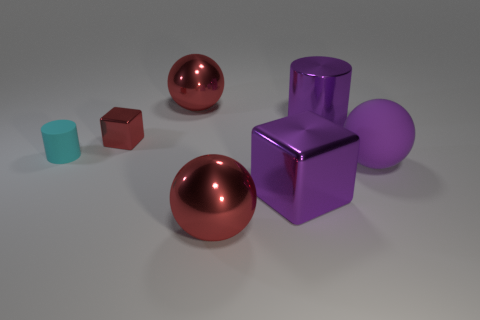There is a sphere that is behind the tiny object that is to the right of the small cyan rubber thing; what color is it?
Provide a short and direct response. Red. What size is the metallic object that is both in front of the cyan cylinder and to the left of the large purple cube?
Ensure brevity in your answer.  Large. What number of other objects are there of the same shape as the small red shiny object?
Your answer should be compact. 1. Does the small red thing have the same shape as the big purple thing behind the tiny red object?
Provide a succinct answer. No. There is a purple shiny block; what number of cubes are behind it?
Give a very brief answer. 1. Are there any other things that have the same material as the purple cylinder?
Keep it short and to the point. Yes. Is the shape of the small object that is behind the cyan object the same as  the tiny cyan rubber object?
Make the answer very short. No. There is a big ball behind the large matte ball; what color is it?
Your response must be concise. Red. What shape is the big purple thing that is the same material as the big purple cube?
Offer a very short reply. Cylinder. Are there any other things that have the same color as the small metallic cube?
Your answer should be compact. Yes. 